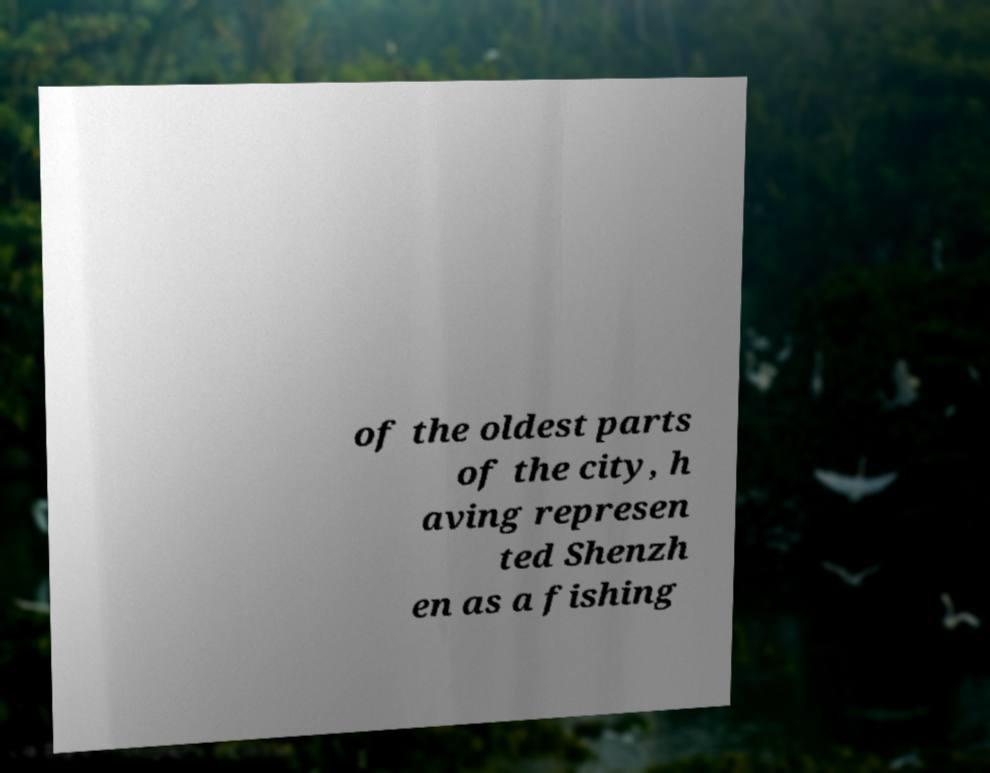Could you extract and type out the text from this image? of the oldest parts of the city, h aving represen ted Shenzh en as a fishing 